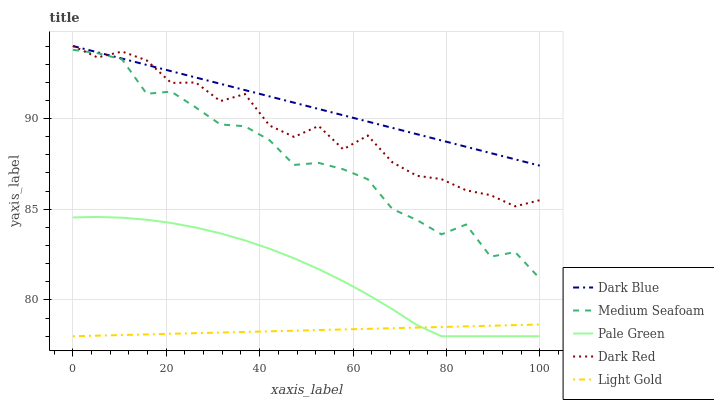Does Light Gold have the minimum area under the curve?
Answer yes or no. Yes. Does Dark Blue have the maximum area under the curve?
Answer yes or no. Yes. Does Pale Green have the minimum area under the curve?
Answer yes or no. No. Does Pale Green have the maximum area under the curve?
Answer yes or no. No. Is Light Gold the smoothest?
Answer yes or no. Yes. Is Dark Red the roughest?
Answer yes or no. Yes. Is Pale Green the smoothest?
Answer yes or no. No. Is Pale Green the roughest?
Answer yes or no. No. Does Pale Green have the lowest value?
Answer yes or no. Yes. Does Medium Seafoam have the lowest value?
Answer yes or no. No. Does Dark Red have the highest value?
Answer yes or no. Yes. Does Pale Green have the highest value?
Answer yes or no. No. Is Pale Green less than Medium Seafoam?
Answer yes or no. Yes. Is Dark Blue greater than Light Gold?
Answer yes or no. Yes. Does Dark Blue intersect Dark Red?
Answer yes or no. Yes. Is Dark Blue less than Dark Red?
Answer yes or no. No. Is Dark Blue greater than Dark Red?
Answer yes or no. No. Does Pale Green intersect Medium Seafoam?
Answer yes or no. No. 